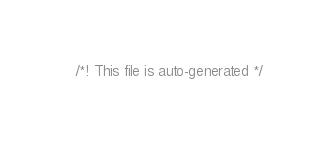Convert code to text. <code><loc_0><loc_0><loc_500><loc_500><_CSS_>/*! This file is auto-generated */</code> 